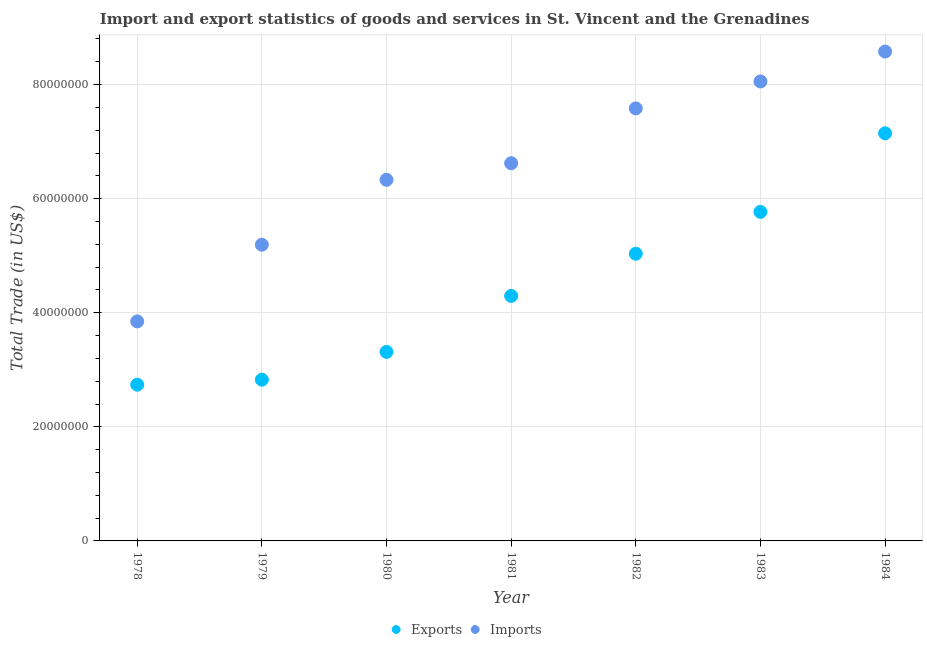How many different coloured dotlines are there?
Your answer should be very brief. 2. Is the number of dotlines equal to the number of legend labels?
Ensure brevity in your answer.  Yes. What is the export of goods and services in 1982?
Make the answer very short. 5.03e+07. Across all years, what is the maximum export of goods and services?
Give a very brief answer. 7.15e+07. Across all years, what is the minimum export of goods and services?
Give a very brief answer. 2.74e+07. In which year was the imports of goods and services maximum?
Provide a short and direct response. 1984. In which year was the imports of goods and services minimum?
Ensure brevity in your answer.  1978. What is the total imports of goods and services in the graph?
Provide a succinct answer. 4.62e+08. What is the difference between the export of goods and services in 1980 and that in 1982?
Provide a succinct answer. -1.72e+07. What is the difference between the imports of goods and services in 1981 and the export of goods and services in 1980?
Keep it short and to the point. 3.31e+07. What is the average imports of goods and services per year?
Keep it short and to the point. 6.60e+07. In the year 1978, what is the difference between the imports of goods and services and export of goods and services?
Give a very brief answer. 1.11e+07. What is the ratio of the export of goods and services in 1979 to that in 1980?
Make the answer very short. 0.85. What is the difference between the highest and the second highest export of goods and services?
Keep it short and to the point. 1.38e+07. What is the difference between the highest and the lowest imports of goods and services?
Offer a terse response. 4.73e+07. Is the export of goods and services strictly greater than the imports of goods and services over the years?
Keep it short and to the point. No. Is the imports of goods and services strictly less than the export of goods and services over the years?
Your response must be concise. No. How many years are there in the graph?
Ensure brevity in your answer.  7. What is the difference between two consecutive major ticks on the Y-axis?
Give a very brief answer. 2.00e+07. Are the values on the major ticks of Y-axis written in scientific E-notation?
Offer a terse response. No. Does the graph contain any zero values?
Your answer should be compact. No. How are the legend labels stacked?
Provide a short and direct response. Horizontal. What is the title of the graph?
Make the answer very short. Import and export statistics of goods and services in St. Vincent and the Grenadines. What is the label or title of the Y-axis?
Make the answer very short. Total Trade (in US$). What is the Total Trade (in US$) of Exports in 1978?
Your response must be concise. 2.74e+07. What is the Total Trade (in US$) in Imports in 1978?
Provide a succinct answer. 3.85e+07. What is the Total Trade (in US$) in Exports in 1979?
Make the answer very short. 2.83e+07. What is the Total Trade (in US$) of Imports in 1979?
Your answer should be very brief. 5.19e+07. What is the Total Trade (in US$) in Exports in 1980?
Your answer should be compact. 3.31e+07. What is the Total Trade (in US$) of Imports in 1980?
Make the answer very short. 6.33e+07. What is the Total Trade (in US$) of Exports in 1981?
Ensure brevity in your answer.  4.30e+07. What is the Total Trade (in US$) of Imports in 1981?
Provide a succinct answer. 6.62e+07. What is the Total Trade (in US$) in Exports in 1982?
Provide a short and direct response. 5.03e+07. What is the Total Trade (in US$) in Imports in 1982?
Your answer should be compact. 7.58e+07. What is the Total Trade (in US$) of Exports in 1983?
Offer a very short reply. 5.77e+07. What is the Total Trade (in US$) of Imports in 1983?
Your answer should be compact. 8.05e+07. What is the Total Trade (in US$) in Exports in 1984?
Provide a succinct answer. 7.15e+07. What is the Total Trade (in US$) of Imports in 1984?
Offer a very short reply. 8.58e+07. Across all years, what is the maximum Total Trade (in US$) in Exports?
Offer a terse response. 7.15e+07. Across all years, what is the maximum Total Trade (in US$) of Imports?
Your answer should be very brief. 8.58e+07. Across all years, what is the minimum Total Trade (in US$) in Exports?
Your answer should be compact. 2.74e+07. Across all years, what is the minimum Total Trade (in US$) in Imports?
Give a very brief answer. 3.85e+07. What is the total Total Trade (in US$) of Exports in the graph?
Provide a short and direct response. 3.11e+08. What is the total Total Trade (in US$) in Imports in the graph?
Your answer should be compact. 4.62e+08. What is the difference between the Total Trade (in US$) in Exports in 1978 and that in 1979?
Provide a short and direct response. -8.70e+05. What is the difference between the Total Trade (in US$) of Imports in 1978 and that in 1979?
Provide a short and direct response. -1.34e+07. What is the difference between the Total Trade (in US$) in Exports in 1978 and that in 1980?
Make the answer very short. -5.74e+06. What is the difference between the Total Trade (in US$) of Imports in 1978 and that in 1980?
Your answer should be compact. -2.48e+07. What is the difference between the Total Trade (in US$) of Exports in 1978 and that in 1981?
Give a very brief answer. -1.56e+07. What is the difference between the Total Trade (in US$) in Imports in 1978 and that in 1981?
Provide a short and direct response. -2.77e+07. What is the difference between the Total Trade (in US$) in Exports in 1978 and that in 1982?
Your answer should be compact. -2.30e+07. What is the difference between the Total Trade (in US$) in Imports in 1978 and that in 1982?
Your answer should be compact. -3.73e+07. What is the difference between the Total Trade (in US$) in Exports in 1978 and that in 1983?
Give a very brief answer. -3.03e+07. What is the difference between the Total Trade (in US$) of Imports in 1978 and that in 1983?
Ensure brevity in your answer.  -4.21e+07. What is the difference between the Total Trade (in US$) of Exports in 1978 and that in 1984?
Ensure brevity in your answer.  -4.41e+07. What is the difference between the Total Trade (in US$) of Imports in 1978 and that in 1984?
Give a very brief answer. -4.73e+07. What is the difference between the Total Trade (in US$) in Exports in 1979 and that in 1980?
Ensure brevity in your answer.  -4.87e+06. What is the difference between the Total Trade (in US$) in Imports in 1979 and that in 1980?
Provide a succinct answer. -1.14e+07. What is the difference between the Total Trade (in US$) in Exports in 1979 and that in 1981?
Provide a succinct answer. -1.47e+07. What is the difference between the Total Trade (in US$) of Imports in 1979 and that in 1981?
Give a very brief answer. -1.43e+07. What is the difference between the Total Trade (in US$) in Exports in 1979 and that in 1982?
Provide a succinct answer. -2.21e+07. What is the difference between the Total Trade (in US$) in Imports in 1979 and that in 1982?
Offer a very short reply. -2.39e+07. What is the difference between the Total Trade (in US$) of Exports in 1979 and that in 1983?
Give a very brief answer. -2.94e+07. What is the difference between the Total Trade (in US$) of Imports in 1979 and that in 1983?
Make the answer very short. -2.86e+07. What is the difference between the Total Trade (in US$) in Exports in 1979 and that in 1984?
Ensure brevity in your answer.  -4.32e+07. What is the difference between the Total Trade (in US$) in Imports in 1979 and that in 1984?
Your answer should be very brief. -3.39e+07. What is the difference between the Total Trade (in US$) of Exports in 1980 and that in 1981?
Offer a terse response. -9.82e+06. What is the difference between the Total Trade (in US$) of Imports in 1980 and that in 1981?
Offer a terse response. -2.91e+06. What is the difference between the Total Trade (in US$) of Exports in 1980 and that in 1982?
Provide a succinct answer. -1.72e+07. What is the difference between the Total Trade (in US$) in Imports in 1980 and that in 1982?
Keep it short and to the point. -1.25e+07. What is the difference between the Total Trade (in US$) in Exports in 1980 and that in 1983?
Your answer should be very brief. -2.45e+07. What is the difference between the Total Trade (in US$) of Imports in 1980 and that in 1983?
Your response must be concise. -1.72e+07. What is the difference between the Total Trade (in US$) of Exports in 1980 and that in 1984?
Your answer should be very brief. -3.83e+07. What is the difference between the Total Trade (in US$) of Imports in 1980 and that in 1984?
Provide a succinct answer. -2.25e+07. What is the difference between the Total Trade (in US$) of Exports in 1981 and that in 1982?
Make the answer very short. -7.39e+06. What is the difference between the Total Trade (in US$) in Imports in 1981 and that in 1982?
Give a very brief answer. -9.60e+06. What is the difference between the Total Trade (in US$) of Exports in 1981 and that in 1983?
Keep it short and to the point. -1.47e+07. What is the difference between the Total Trade (in US$) of Imports in 1981 and that in 1983?
Provide a succinct answer. -1.43e+07. What is the difference between the Total Trade (in US$) of Exports in 1981 and that in 1984?
Offer a terse response. -2.85e+07. What is the difference between the Total Trade (in US$) in Imports in 1981 and that in 1984?
Offer a terse response. -1.96e+07. What is the difference between the Total Trade (in US$) of Exports in 1982 and that in 1983?
Offer a very short reply. -7.34e+06. What is the difference between the Total Trade (in US$) in Imports in 1982 and that in 1983?
Make the answer very short. -4.73e+06. What is the difference between the Total Trade (in US$) of Exports in 1982 and that in 1984?
Make the answer very short. -2.11e+07. What is the difference between the Total Trade (in US$) in Imports in 1982 and that in 1984?
Offer a terse response. -9.97e+06. What is the difference between the Total Trade (in US$) of Exports in 1983 and that in 1984?
Keep it short and to the point. -1.38e+07. What is the difference between the Total Trade (in US$) in Imports in 1983 and that in 1984?
Give a very brief answer. -5.25e+06. What is the difference between the Total Trade (in US$) of Exports in 1978 and the Total Trade (in US$) of Imports in 1979?
Ensure brevity in your answer.  -2.45e+07. What is the difference between the Total Trade (in US$) of Exports in 1978 and the Total Trade (in US$) of Imports in 1980?
Make the answer very short. -3.59e+07. What is the difference between the Total Trade (in US$) in Exports in 1978 and the Total Trade (in US$) in Imports in 1981?
Give a very brief answer. -3.88e+07. What is the difference between the Total Trade (in US$) in Exports in 1978 and the Total Trade (in US$) in Imports in 1982?
Offer a terse response. -4.84e+07. What is the difference between the Total Trade (in US$) of Exports in 1978 and the Total Trade (in US$) of Imports in 1983?
Offer a very short reply. -5.32e+07. What is the difference between the Total Trade (in US$) of Exports in 1978 and the Total Trade (in US$) of Imports in 1984?
Your answer should be very brief. -5.84e+07. What is the difference between the Total Trade (in US$) in Exports in 1979 and the Total Trade (in US$) in Imports in 1980?
Make the answer very short. -3.50e+07. What is the difference between the Total Trade (in US$) of Exports in 1979 and the Total Trade (in US$) of Imports in 1981?
Keep it short and to the point. -3.80e+07. What is the difference between the Total Trade (in US$) in Exports in 1979 and the Total Trade (in US$) in Imports in 1982?
Your response must be concise. -4.76e+07. What is the difference between the Total Trade (in US$) of Exports in 1979 and the Total Trade (in US$) of Imports in 1983?
Provide a short and direct response. -5.23e+07. What is the difference between the Total Trade (in US$) of Exports in 1979 and the Total Trade (in US$) of Imports in 1984?
Your answer should be compact. -5.75e+07. What is the difference between the Total Trade (in US$) in Exports in 1980 and the Total Trade (in US$) in Imports in 1981?
Make the answer very short. -3.31e+07. What is the difference between the Total Trade (in US$) of Exports in 1980 and the Total Trade (in US$) of Imports in 1982?
Ensure brevity in your answer.  -4.27e+07. What is the difference between the Total Trade (in US$) of Exports in 1980 and the Total Trade (in US$) of Imports in 1983?
Ensure brevity in your answer.  -4.74e+07. What is the difference between the Total Trade (in US$) in Exports in 1980 and the Total Trade (in US$) in Imports in 1984?
Keep it short and to the point. -5.27e+07. What is the difference between the Total Trade (in US$) of Exports in 1981 and the Total Trade (in US$) of Imports in 1982?
Provide a succinct answer. -3.29e+07. What is the difference between the Total Trade (in US$) of Exports in 1981 and the Total Trade (in US$) of Imports in 1983?
Provide a succinct answer. -3.76e+07. What is the difference between the Total Trade (in US$) of Exports in 1981 and the Total Trade (in US$) of Imports in 1984?
Make the answer very short. -4.28e+07. What is the difference between the Total Trade (in US$) in Exports in 1982 and the Total Trade (in US$) in Imports in 1983?
Make the answer very short. -3.02e+07. What is the difference between the Total Trade (in US$) in Exports in 1982 and the Total Trade (in US$) in Imports in 1984?
Your answer should be very brief. -3.54e+07. What is the difference between the Total Trade (in US$) in Exports in 1983 and the Total Trade (in US$) in Imports in 1984?
Your answer should be very brief. -2.81e+07. What is the average Total Trade (in US$) in Exports per year?
Your answer should be very brief. 4.45e+07. What is the average Total Trade (in US$) of Imports per year?
Give a very brief answer. 6.60e+07. In the year 1978, what is the difference between the Total Trade (in US$) of Exports and Total Trade (in US$) of Imports?
Offer a terse response. -1.11e+07. In the year 1979, what is the difference between the Total Trade (in US$) of Exports and Total Trade (in US$) of Imports?
Offer a terse response. -2.37e+07. In the year 1980, what is the difference between the Total Trade (in US$) in Exports and Total Trade (in US$) in Imports?
Offer a terse response. -3.02e+07. In the year 1981, what is the difference between the Total Trade (in US$) in Exports and Total Trade (in US$) in Imports?
Provide a short and direct response. -2.33e+07. In the year 1982, what is the difference between the Total Trade (in US$) of Exports and Total Trade (in US$) of Imports?
Give a very brief answer. -2.55e+07. In the year 1983, what is the difference between the Total Trade (in US$) of Exports and Total Trade (in US$) of Imports?
Provide a succinct answer. -2.29e+07. In the year 1984, what is the difference between the Total Trade (in US$) of Exports and Total Trade (in US$) of Imports?
Your response must be concise. -1.43e+07. What is the ratio of the Total Trade (in US$) in Exports in 1978 to that in 1979?
Make the answer very short. 0.97. What is the ratio of the Total Trade (in US$) in Imports in 1978 to that in 1979?
Your response must be concise. 0.74. What is the ratio of the Total Trade (in US$) in Exports in 1978 to that in 1980?
Make the answer very short. 0.83. What is the ratio of the Total Trade (in US$) of Imports in 1978 to that in 1980?
Your response must be concise. 0.61. What is the ratio of the Total Trade (in US$) of Exports in 1978 to that in 1981?
Offer a very short reply. 0.64. What is the ratio of the Total Trade (in US$) in Imports in 1978 to that in 1981?
Make the answer very short. 0.58. What is the ratio of the Total Trade (in US$) of Exports in 1978 to that in 1982?
Your answer should be very brief. 0.54. What is the ratio of the Total Trade (in US$) of Imports in 1978 to that in 1982?
Make the answer very short. 0.51. What is the ratio of the Total Trade (in US$) in Exports in 1978 to that in 1983?
Give a very brief answer. 0.47. What is the ratio of the Total Trade (in US$) in Imports in 1978 to that in 1983?
Your answer should be compact. 0.48. What is the ratio of the Total Trade (in US$) of Exports in 1978 to that in 1984?
Ensure brevity in your answer.  0.38. What is the ratio of the Total Trade (in US$) of Imports in 1978 to that in 1984?
Ensure brevity in your answer.  0.45. What is the ratio of the Total Trade (in US$) of Exports in 1979 to that in 1980?
Your answer should be compact. 0.85. What is the ratio of the Total Trade (in US$) of Imports in 1979 to that in 1980?
Offer a very short reply. 0.82. What is the ratio of the Total Trade (in US$) in Exports in 1979 to that in 1981?
Offer a terse response. 0.66. What is the ratio of the Total Trade (in US$) in Imports in 1979 to that in 1981?
Keep it short and to the point. 0.78. What is the ratio of the Total Trade (in US$) of Exports in 1979 to that in 1982?
Provide a succinct answer. 0.56. What is the ratio of the Total Trade (in US$) of Imports in 1979 to that in 1982?
Offer a terse response. 0.68. What is the ratio of the Total Trade (in US$) of Exports in 1979 to that in 1983?
Keep it short and to the point. 0.49. What is the ratio of the Total Trade (in US$) in Imports in 1979 to that in 1983?
Offer a very short reply. 0.64. What is the ratio of the Total Trade (in US$) in Exports in 1979 to that in 1984?
Make the answer very short. 0.4. What is the ratio of the Total Trade (in US$) in Imports in 1979 to that in 1984?
Your answer should be very brief. 0.61. What is the ratio of the Total Trade (in US$) of Exports in 1980 to that in 1981?
Keep it short and to the point. 0.77. What is the ratio of the Total Trade (in US$) in Imports in 1980 to that in 1981?
Ensure brevity in your answer.  0.96. What is the ratio of the Total Trade (in US$) of Exports in 1980 to that in 1982?
Your answer should be very brief. 0.66. What is the ratio of the Total Trade (in US$) in Imports in 1980 to that in 1982?
Make the answer very short. 0.83. What is the ratio of the Total Trade (in US$) in Exports in 1980 to that in 1983?
Make the answer very short. 0.57. What is the ratio of the Total Trade (in US$) of Imports in 1980 to that in 1983?
Keep it short and to the point. 0.79. What is the ratio of the Total Trade (in US$) of Exports in 1980 to that in 1984?
Offer a terse response. 0.46. What is the ratio of the Total Trade (in US$) in Imports in 1980 to that in 1984?
Ensure brevity in your answer.  0.74. What is the ratio of the Total Trade (in US$) of Exports in 1981 to that in 1982?
Keep it short and to the point. 0.85. What is the ratio of the Total Trade (in US$) in Imports in 1981 to that in 1982?
Ensure brevity in your answer.  0.87. What is the ratio of the Total Trade (in US$) in Exports in 1981 to that in 1983?
Ensure brevity in your answer.  0.74. What is the ratio of the Total Trade (in US$) of Imports in 1981 to that in 1983?
Your answer should be compact. 0.82. What is the ratio of the Total Trade (in US$) in Exports in 1981 to that in 1984?
Your answer should be compact. 0.6. What is the ratio of the Total Trade (in US$) in Imports in 1981 to that in 1984?
Make the answer very short. 0.77. What is the ratio of the Total Trade (in US$) in Exports in 1982 to that in 1983?
Your response must be concise. 0.87. What is the ratio of the Total Trade (in US$) of Imports in 1982 to that in 1983?
Your response must be concise. 0.94. What is the ratio of the Total Trade (in US$) of Exports in 1982 to that in 1984?
Your answer should be compact. 0.7. What is the ratio of the Total Trade (in US$) in Imports in 1982 to that in 1984?
Ensure brevity in your answer.  0.88. What is the ratio of the Total Trade (in US$) in Exports in 1983 to that in 1984?
Your answer should be very brief. 0.81. What is the ratio of the Total Trade (in US$) of Imports in 1983 to that in 1984?
Provide a short and direct response. 0.94. What is the difference between the highest and the second highest Total Trade (in US$) of Exports?
Make the answer very short. 1.38e+07. What is the difference between the highest and the second highest Total Trade (in US$) of Imports?
Provide a succinct answer. 5.25e+06. What is the difference between the highest and the lowest Total Trade (in US$) of Exports?
Give a very brief answer. 4.41e+07. What is the difference between the highest and the lowest Total Trade (in US$) in Imports?
Keep it short and to the point. 4.73e+07. 